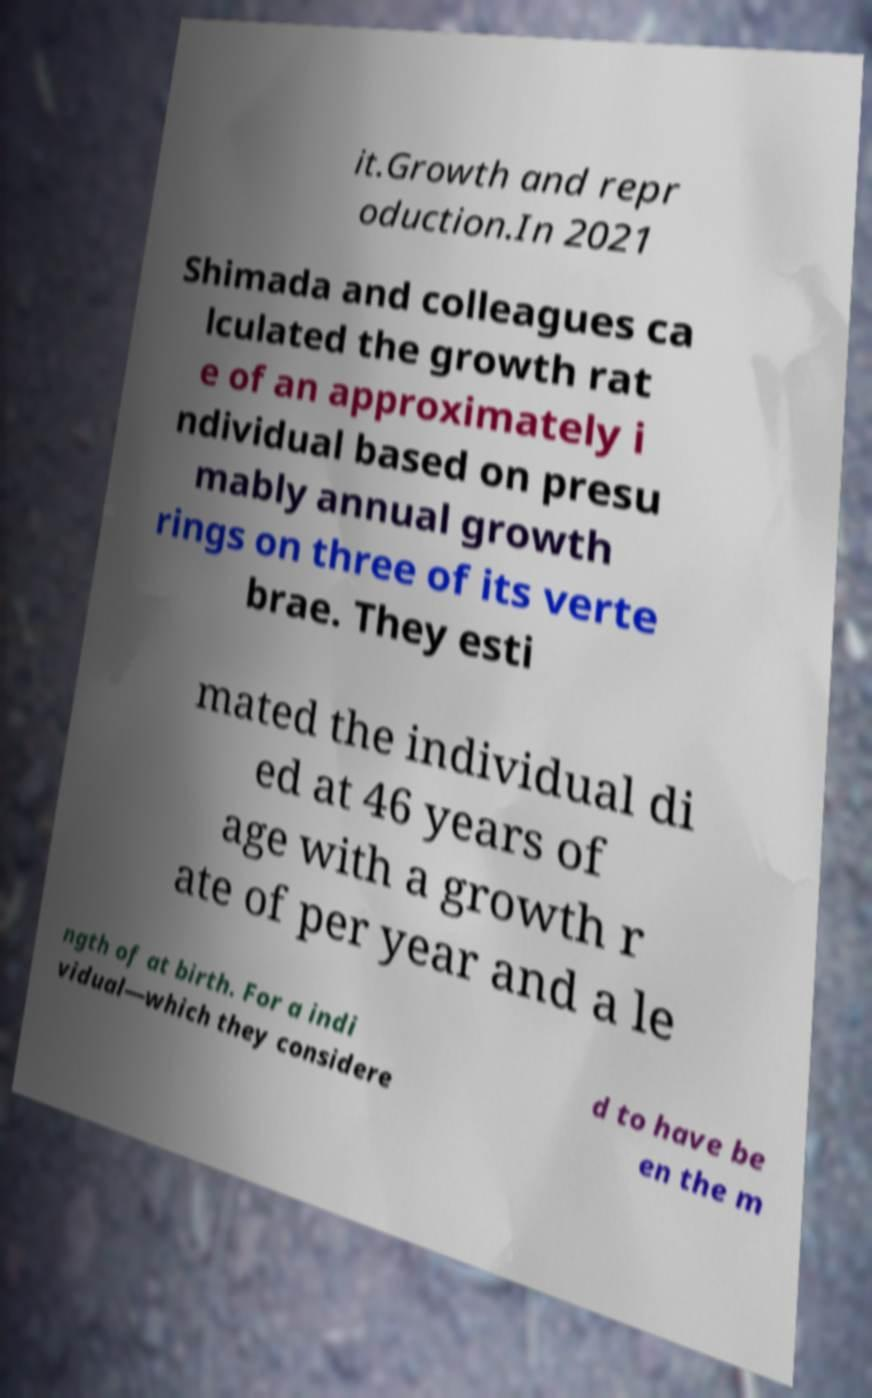Could you extract and type out the text from this image? it.Growth and repr oduction.In 2021 Shimada and colleagues ca lculated the growth rat e of an approximately i ndividual based on presu mably annual growth rings on three of its verte brae. They esti mated the individual di ed at 46 years of age with a growth r ate of per year and a le ngth of at birth. For a indi vidual—which they considere d to have be en the m 